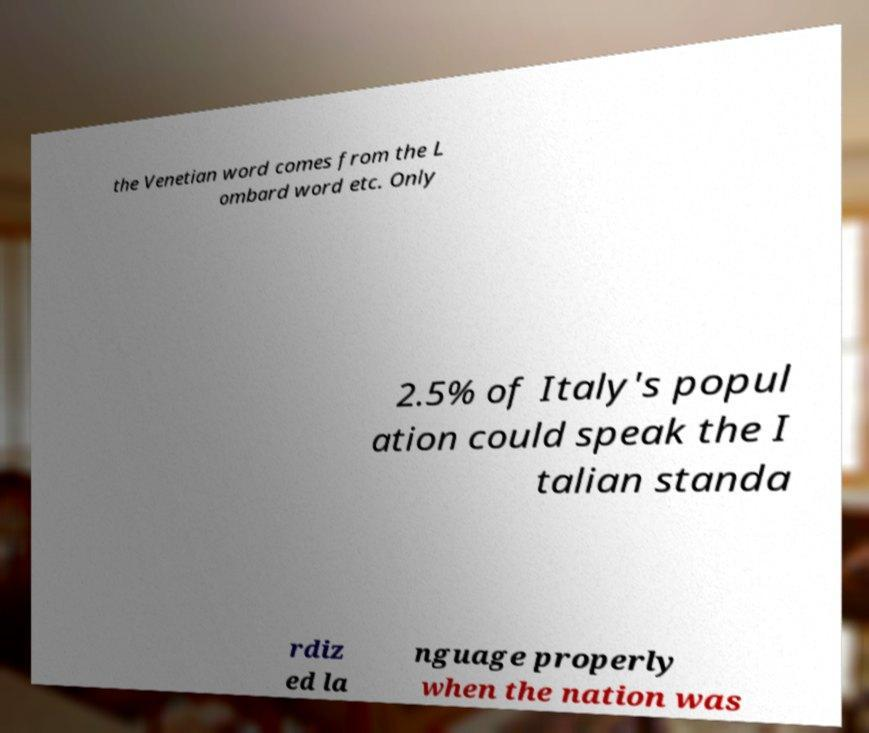What messages or text are displayed in this image? I need them in a readable, typed format. the Venetian word comes from the L ombard word etc. Only 2.5% of Italy's popul ation could speak the I talian standa rdiz ed la nguage properly when the nation was 